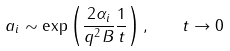Convert formula to latex. <formula><loc_0><loc_0><loc_500><loc_500>a _ { i } \sim \exp \left ( \frac { 2 \alpha _ { i } } { q ^ { 2 } B } \frac { 1 } { t } \right ) , \quad t \rightarrow 0</formula> 